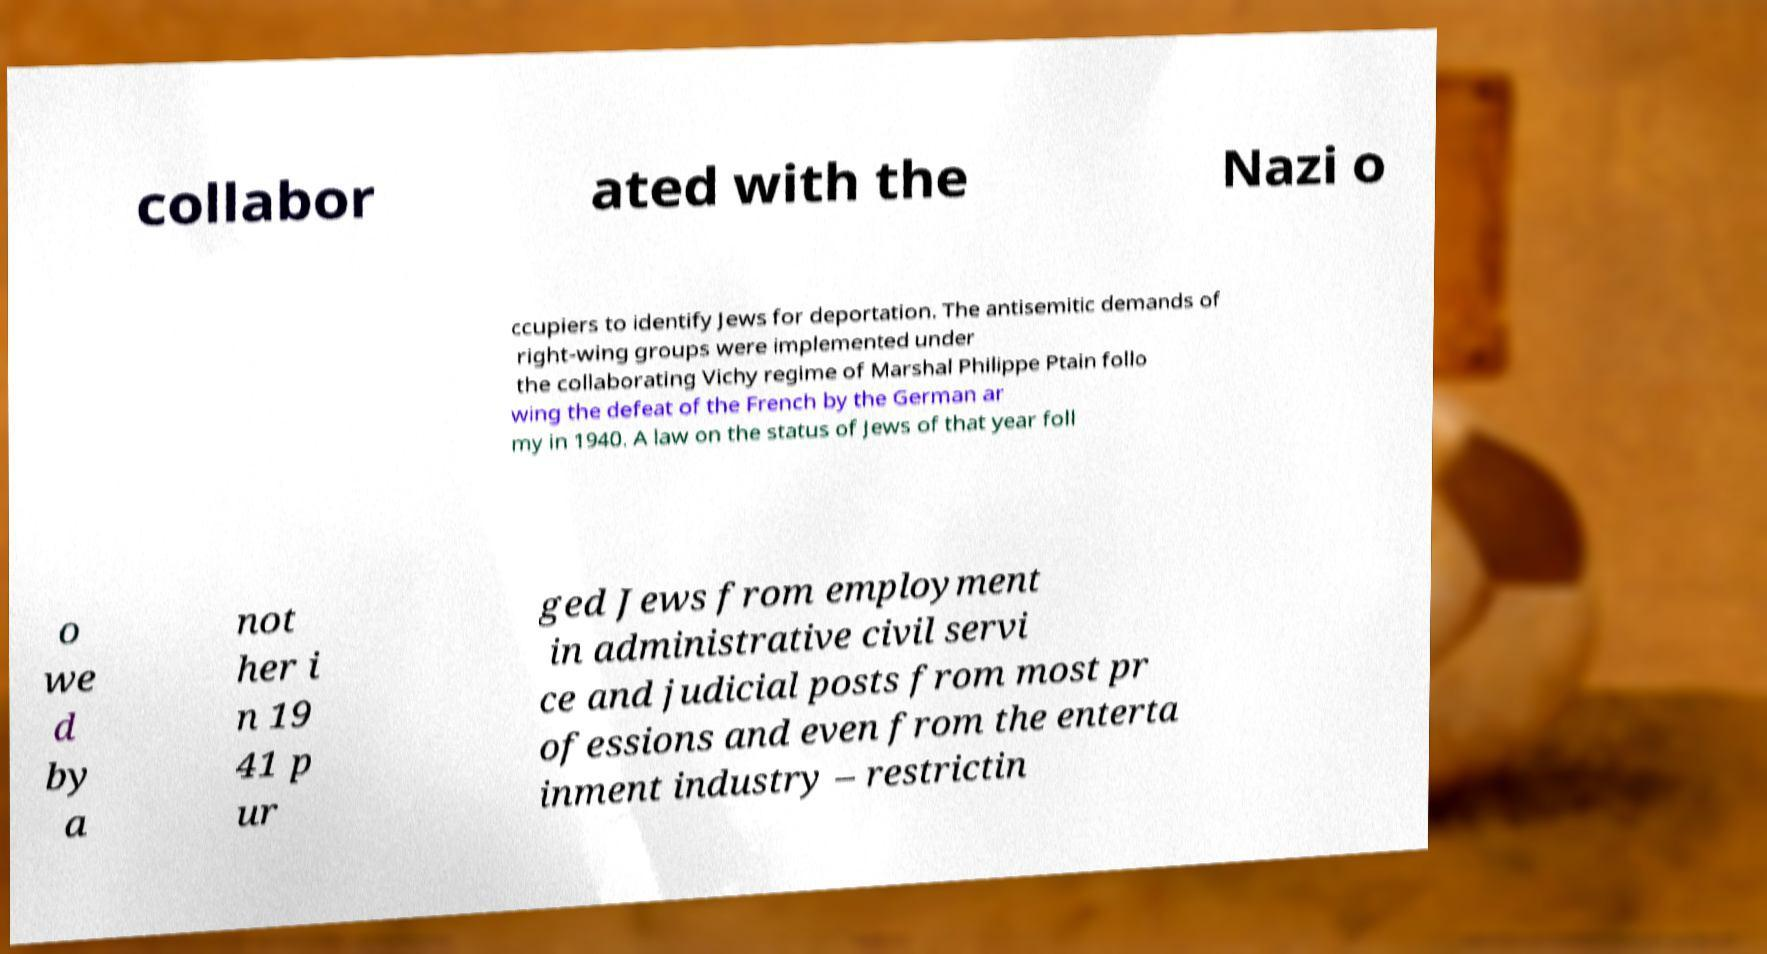Can you accurately transcribe the text from the provided image for me? collabor ated with the Nazi o ccupiers to identify Jews for deportation. The antisemitic demands of right-wing groups were implemented under the collaborating Vichy regime of Marshal Philippe Ptain follo wing the defeat of the French by the German ar my in 1940. A law on the status of Jews of that year foll o we d by a not her i n 19 41 p ur ged Jews from employment in administrative civil servi ce and judicial posts from most pr ofessions and even from the enterta inment industry – restrictin 